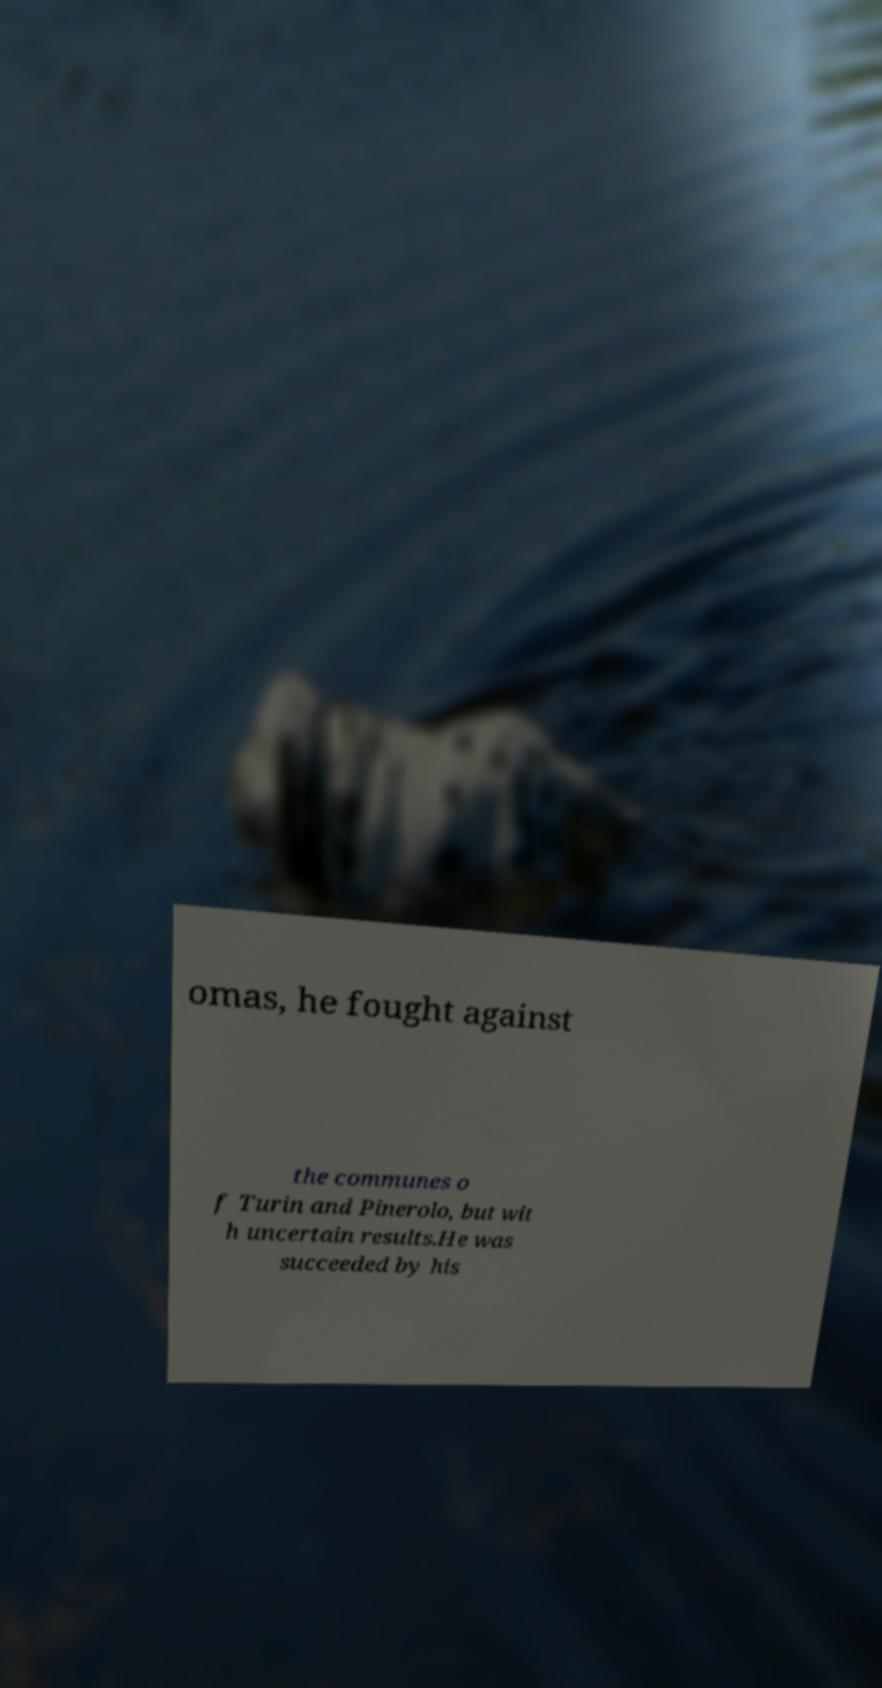Please read and relay the text visible in this image. What does it say? omas, he fought against the communes o f Turin and Pinerolo, but wit h uncertain results.He was succeeded by his 